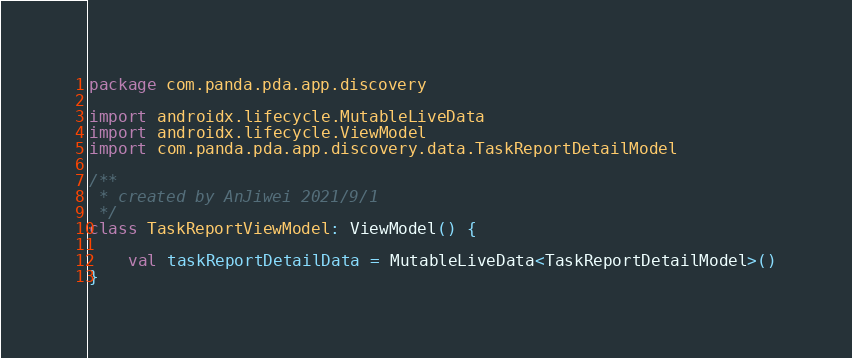<code> <loc_0><loc_0><loc_500><loc_500><_Kotlin_>package com.panda.pda.app.discovery

import androidx.lifecycle.MutableLiveData
import androidx.lifecycle.ViewModel
import com.panda.pda.app.discovery.data.TaskReportDetailModel

/**
 * created by AnJiwei 2021/9/1
 */
class TaskReportViewModel: ViewModel() {

    val taskReportDetailData = MutableLiveData<TaskReportDetailModel>()
}</code> 